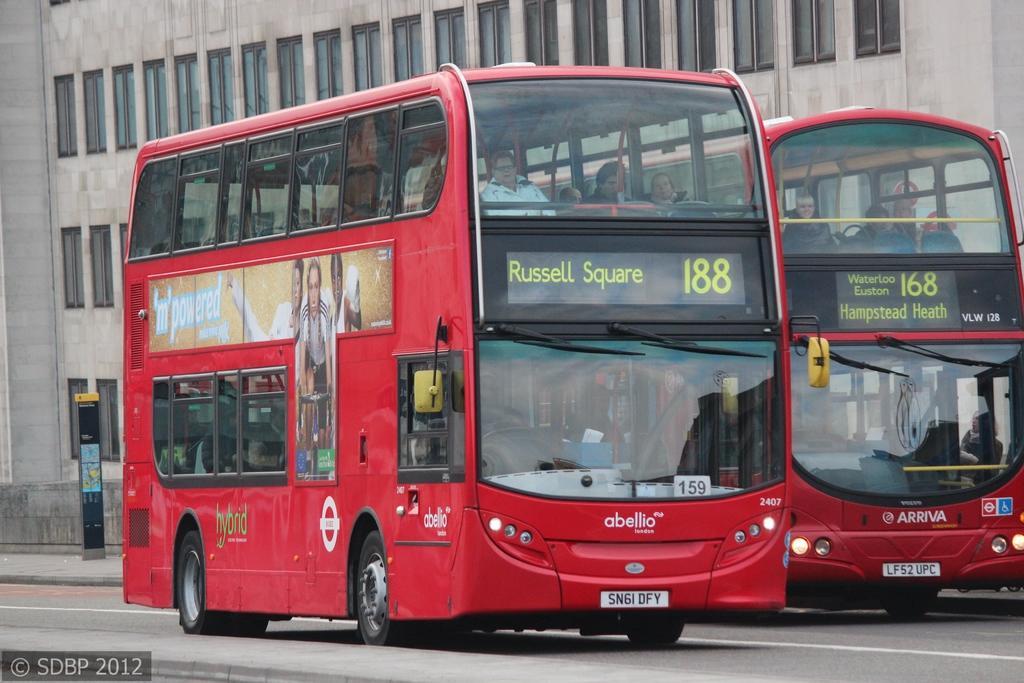In one or two sentences, can you explain what this image depicts? In this picture we can see many peoples were inside the bus. These buses are running on the road. In the background we can see the building. On the left there is a board near to the wall. In the bottom left corner there is a watermark. 